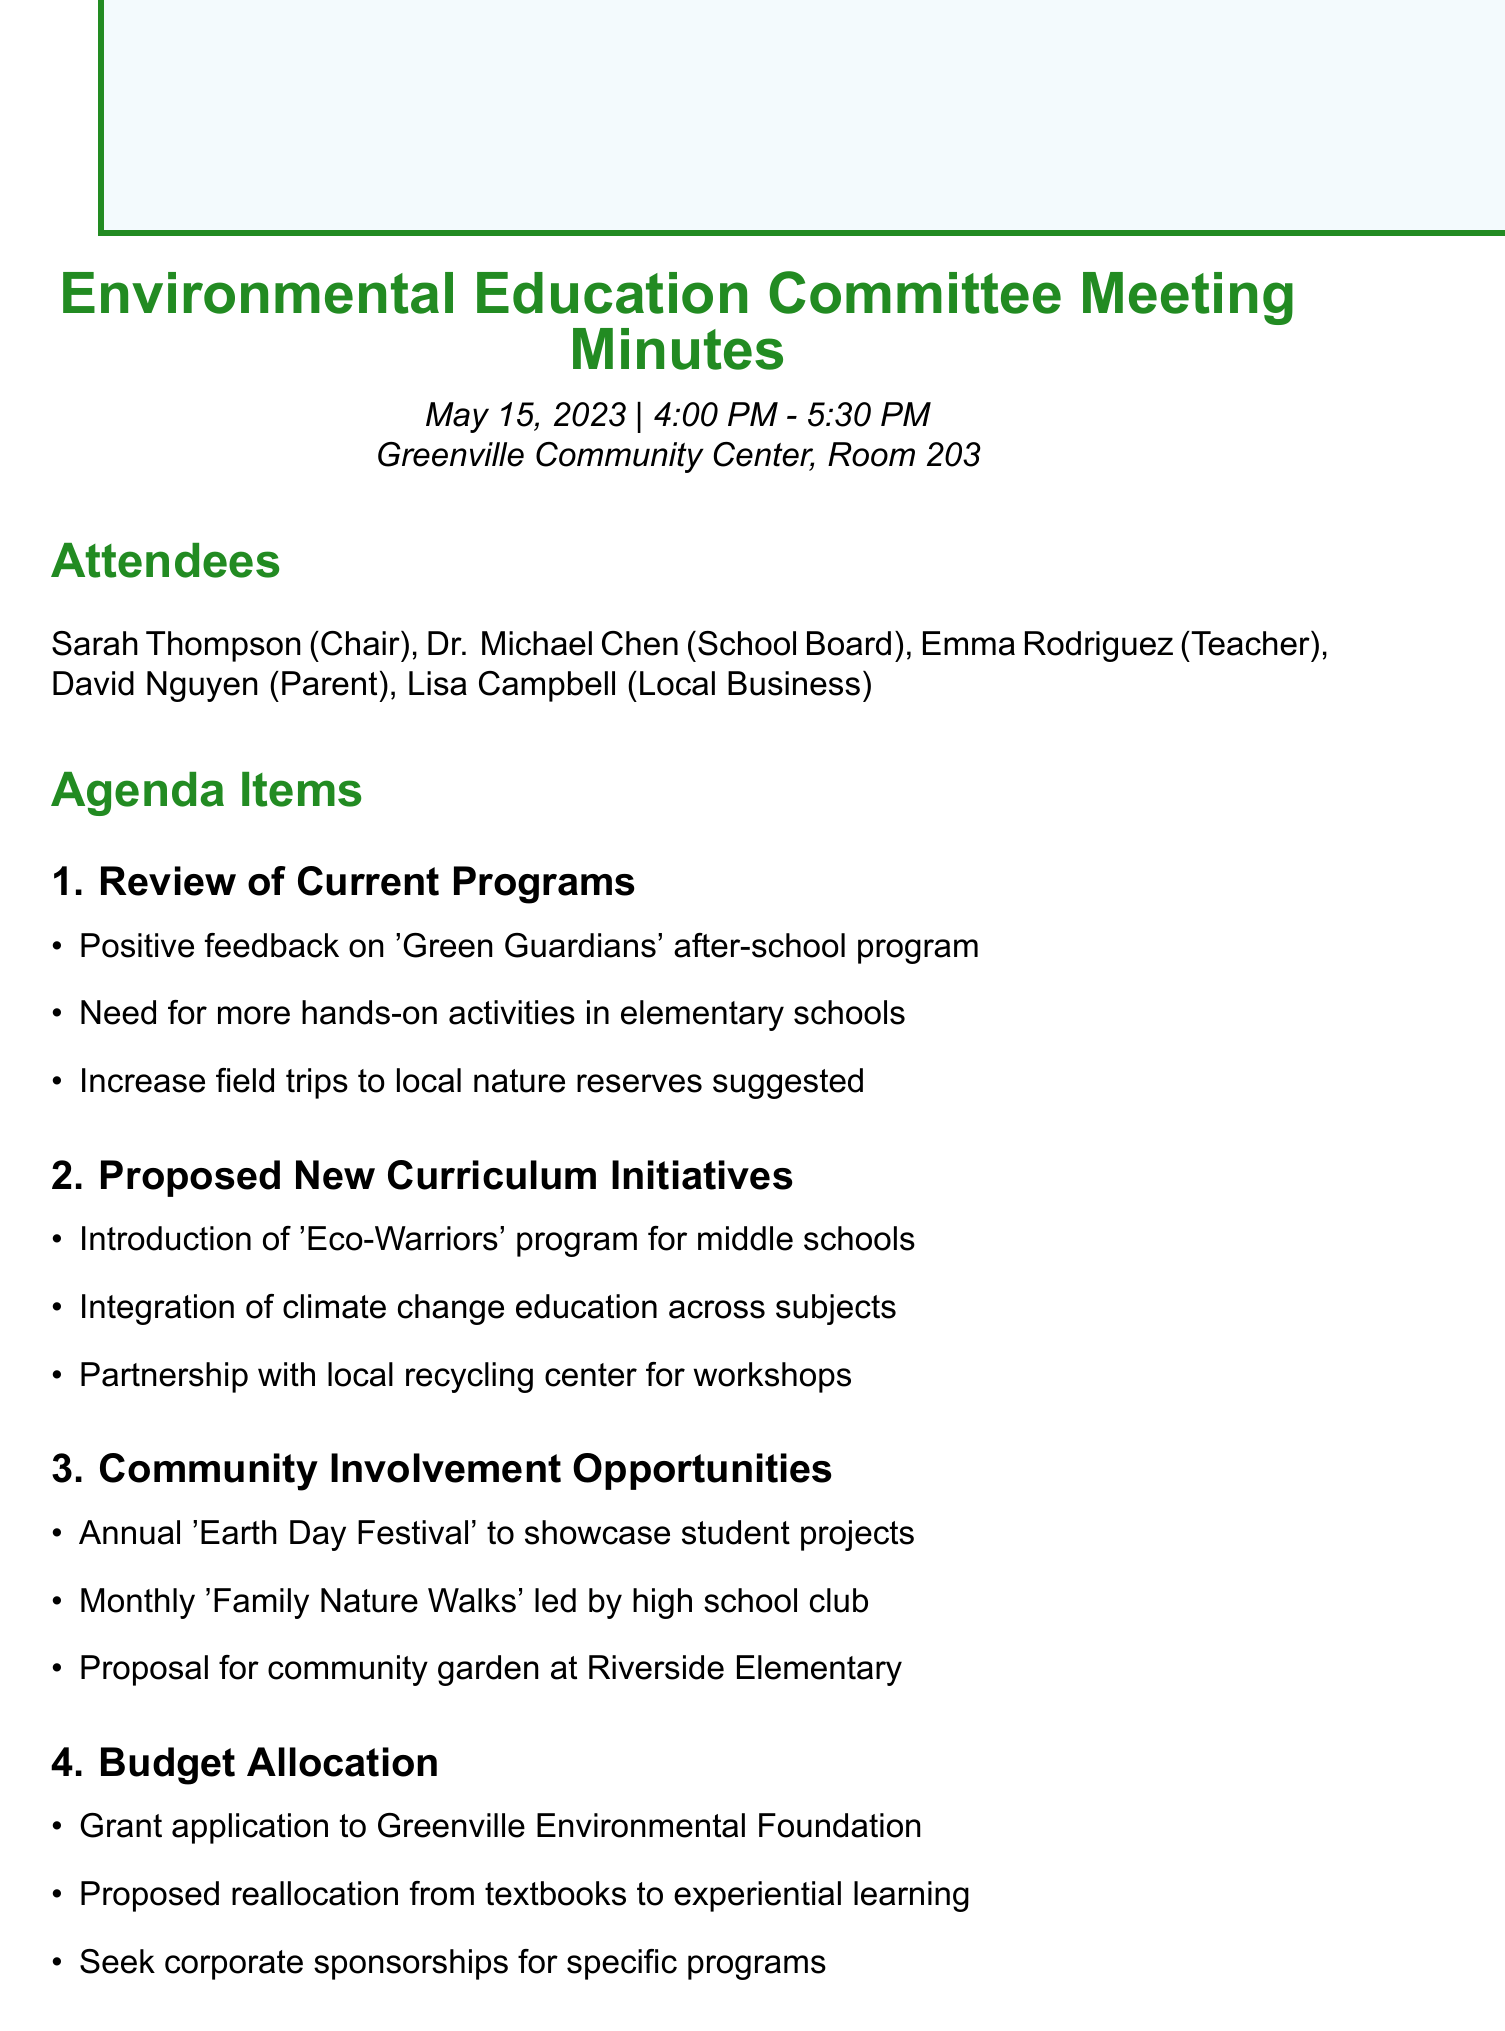what is the date of the meeting? The date of the meeting is stated at the beginning of the document as May 15, 2023.
Answer: May 15, 2023 who chaired the meeting? The document indicates that Sarah Thompson was the chair of the meeting.
Answer: Sarah Thompson what program received positive feedback? The meeting minutes mention the 'Green Guardians' after-school program received positive feedback.
Answer: 'Green Guardians' how many attendees were present? The document lists five attendees present during the meeting.
Answer: Five what initiative is proposed for middle schools? The proposed initiative for middle schools is the 'Eco-Warriors' program.
Answer: 'Eco-Warriors' program what is the next meeting's date? The next meeting's date is provided in the closing section of the document as June 19, 2023.
Answer: June 19, 2023 who is responsible for drafting the 'Eco-Warriors' proposal? The action items state that Emma is responsible for drafting the proposal.
Answer: Emma what is suggested for community involvement? The document suggests an annual 'Earth Day Festival' to showcase student projects as a community involvement opportunity.
Answer: Annual 'Earth Day Festival' which organization was a grant application submitted to? The grant application is submitted to the Greenville Environmental Foundation as noted in the budget allocation section.
Answer: Greenville Environmental Foundation 